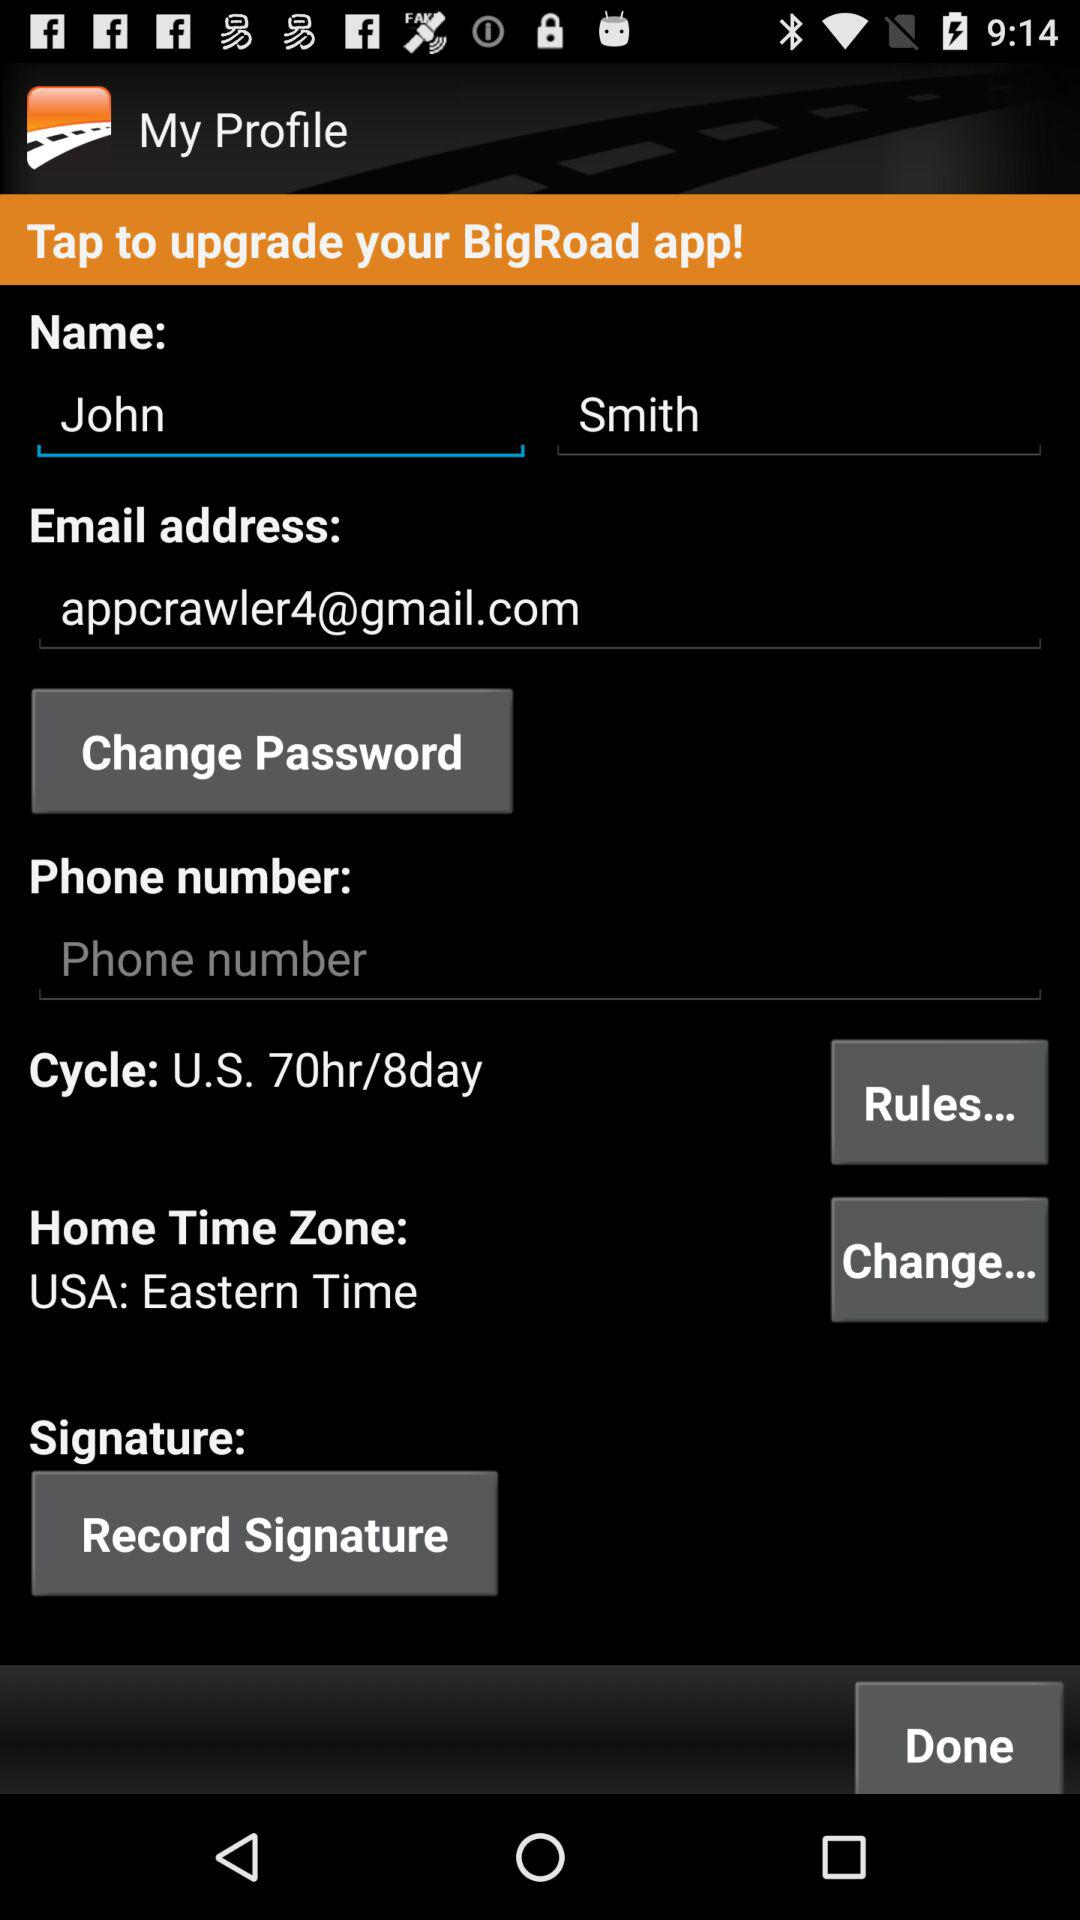What's the email address? The email address is appcrawler4@gmail.com. 